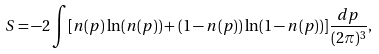<formula> <loc_0><loc_0><loc_500><loc_500>S = - 2 \int [ n ( { p } ) \ln ( n ( { p } ) ) + ( 1 - n ( { p } ) ) \ln ( 1 - n ( { p } ) ) ] \frac { d { p } } { ( 2 \pi ) ^ { 3 } } ,</formula> 